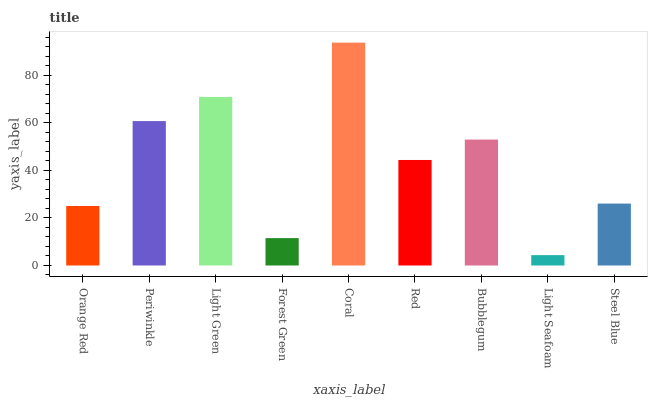Is Periwinkle the minimum?
Answer yes or no. No. Is Periwinkle the maximum?
Answer yes or no. No. Is Periwinkle greater than Orange Red?
Answer yes or no. Yes. Is Orange Red less than Periwinkle?
Answer yes or no. Yes. Is Orange Red greater than Periwinkle?
Answer yes or no. No. Is Periwinkle less than Orange Red?
Answer yes or no. No. Is Red the high median?
Answer yes or no. Yes. Is Red the low median?
Answer yes or no. Yes. Is Light Seafoam the high median?
Answer yes or no. No. Is Light Green the low median?
Answer yes or no. No. 